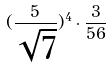<formula> <loc_0><loc_0><loc_500><loc_500>( \frac { 5 } { \sqrt { 7 } } ) ^ { 4 } \cdot \frac { 3 } { 5 6 }</formula> 